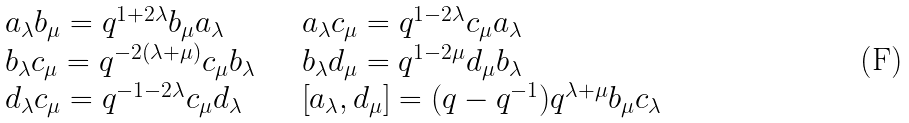<formula> <loc_0><loc_0><loc_500><loc_500>\begin{array} { l l } a _ { \lambda } b _ { \mu } = q ^ { 1 + 2 \lambda } b _ { \mu } a _ { \lambda } \quad & a _ { \lambda } c _ { \mu } = q ^ { 1 - 2 \lambda } c _ { \mu } a _ { \lambda } \\ b _ { \lambda } c _ { \mu } = q ^ { - 2 ( \lambda + \mu ) } c _ { \mu } b _ { \lambda } \quad & b _ { \lambda } d _ { \mu } = q ^ { 1 - 2 \mu } d _ { \mu } b _ { \lambda } \\ d _ { \lambda } c _ { \mu } = q ^ { - 1 - 2 \lambda } c _ { \mu } d _ { \lambda } \quad & \left [ a _ { \lambda } , d _ { \mu } \right ] = ( q - q ^ { - 1 } ) q ^ { \lambda + \mu } b _ { \mu } c _ { \lambda } \end{array}</formula> 